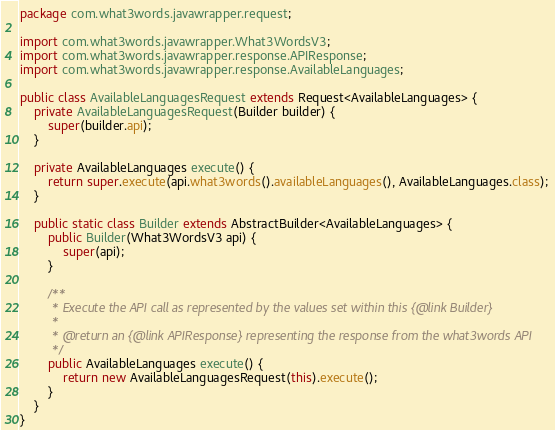<code> <loc_0><loc_0><loc_500><loc_500><_Java_>package com.what3words.javawrapper.request;

import com.what3words.javawrapper.What3WordsV3;
import com.what3words.javawrapper.response.APIResponse;
import com.what3words.javawrapper.response.AvailableLanguages;

public class AvailableLanguagesRequest extends Request<AvailableLanguages> {
    private AvailableLanguagesRequest(Builder builder) {
        super(builder.api);
    }

    private AvailableLanguages execute() {
        return super.execute(api.what3words().availableLanguages(), AvailableLanguages.class);
    }

    public static class Builder extends AbstractBuilder<AvailableLanguages> {
        public Builder(What3WordsV3 api) {
            super(api);
        }

        /**
         * Execute the API call as represented by the values set within this {@link Builder}
         * 
         * @return an {@link APIResponse} representing the response from the what3words API
         */
        public AvailableLanguages execute() {
            return new AvailableLanguagesRequest(this).execute();
        }
    }
}
</code> 